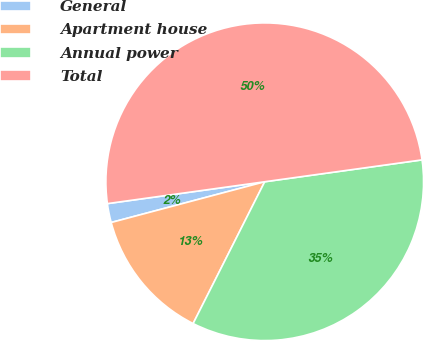Convert chart. <chart><loc_0><loc_0><loc_500><loc_500><pie_chart><fcel>General<fcel>Apartment house<fcel>Annual power<fcel>Total<nl><fcel>1.93%<fcel>13.43%<fcel>34.64%<fcel>50.0%<nl></chart> 